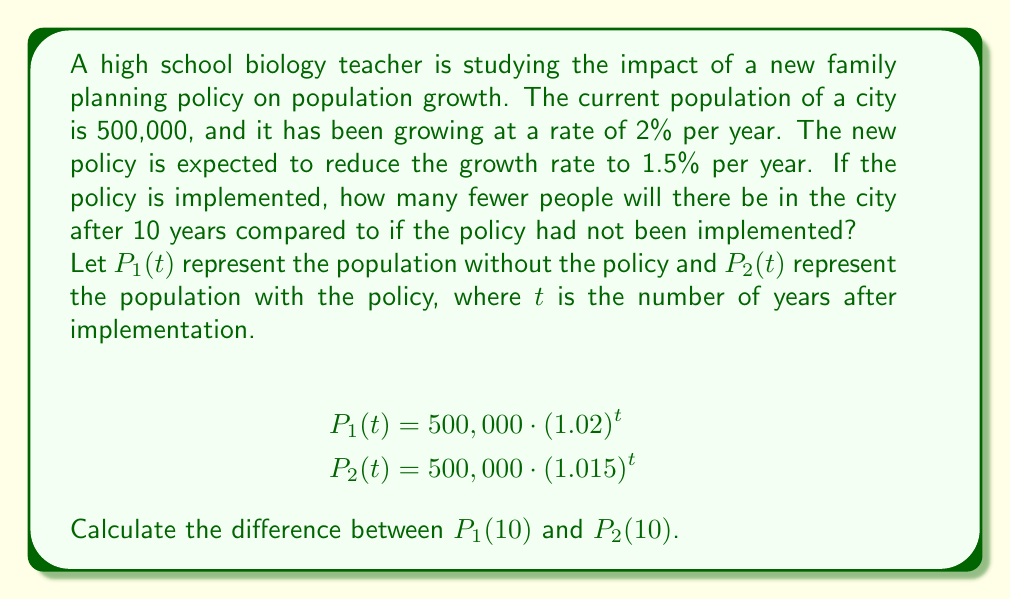Show me your answer to this math problem. To solve this problem, we need to follow these steps:

1. Calculate the population after 10 years without the policy:
   $$P_1(10) = 500,000 \cdot (1.02)^{10}$$

2. Calculate the population after 10 years with the policy:
   $$P_2(10) = 500,000 \cdot (1.015)^{10}$$

3. Find the difference between these two values.

Let's perform the calculations:

1. Without the policy:
   $$P_1(10) = 500,000 \cdot (1.02)^{10} = 500,000 \cdot 1.2189 = 609,450$$

2. With the policy:
   $$P_2(10) = 500,000 \cdot (1.015)^{10} = 500,000 \cdot 1.1605 = 580,250$$

3. Difference:
   $$P_1(10) - P_2(10) = 609,450 - 580,250 = 29,200$$

Therefore, after 10 years, there will be 29,200 fewer people in the city if the new family planning policy is implemented compared to if it had not been implemented.

This question demonstrates the long-term effects of even small changes in population growth rates, which is relevant to both genetics and family planning in a biology curriculum.
Answer: 29,200 fewer people 